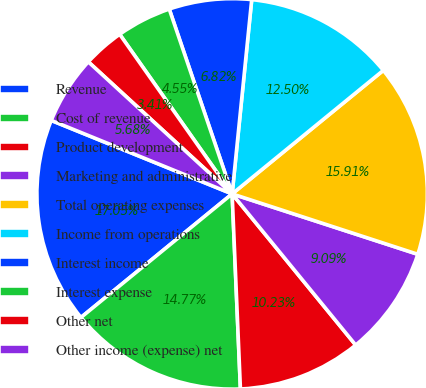<chart> <loc_0><loc_0><loc_500><loc_500><pie_chart><fcel>Revenue<fcel>Cost of revenue<fcel>Product development<fcel>Marketing and administrative<fcel>Total operating expenses<fcel>Income from operations<fcel>Interest income<fcel>Interest expense<fcel>Other net<fcel>Other income (expense) net<nl><fcel>17.05%<fcel>14.77%<fcel>10.23%<fcel>9.09%<fcel>15.91%<fcel>12.5%<fcel>6.82%<fcel>4.55%<fcel>3.41%<fcel>5.68%<nl></chart> 